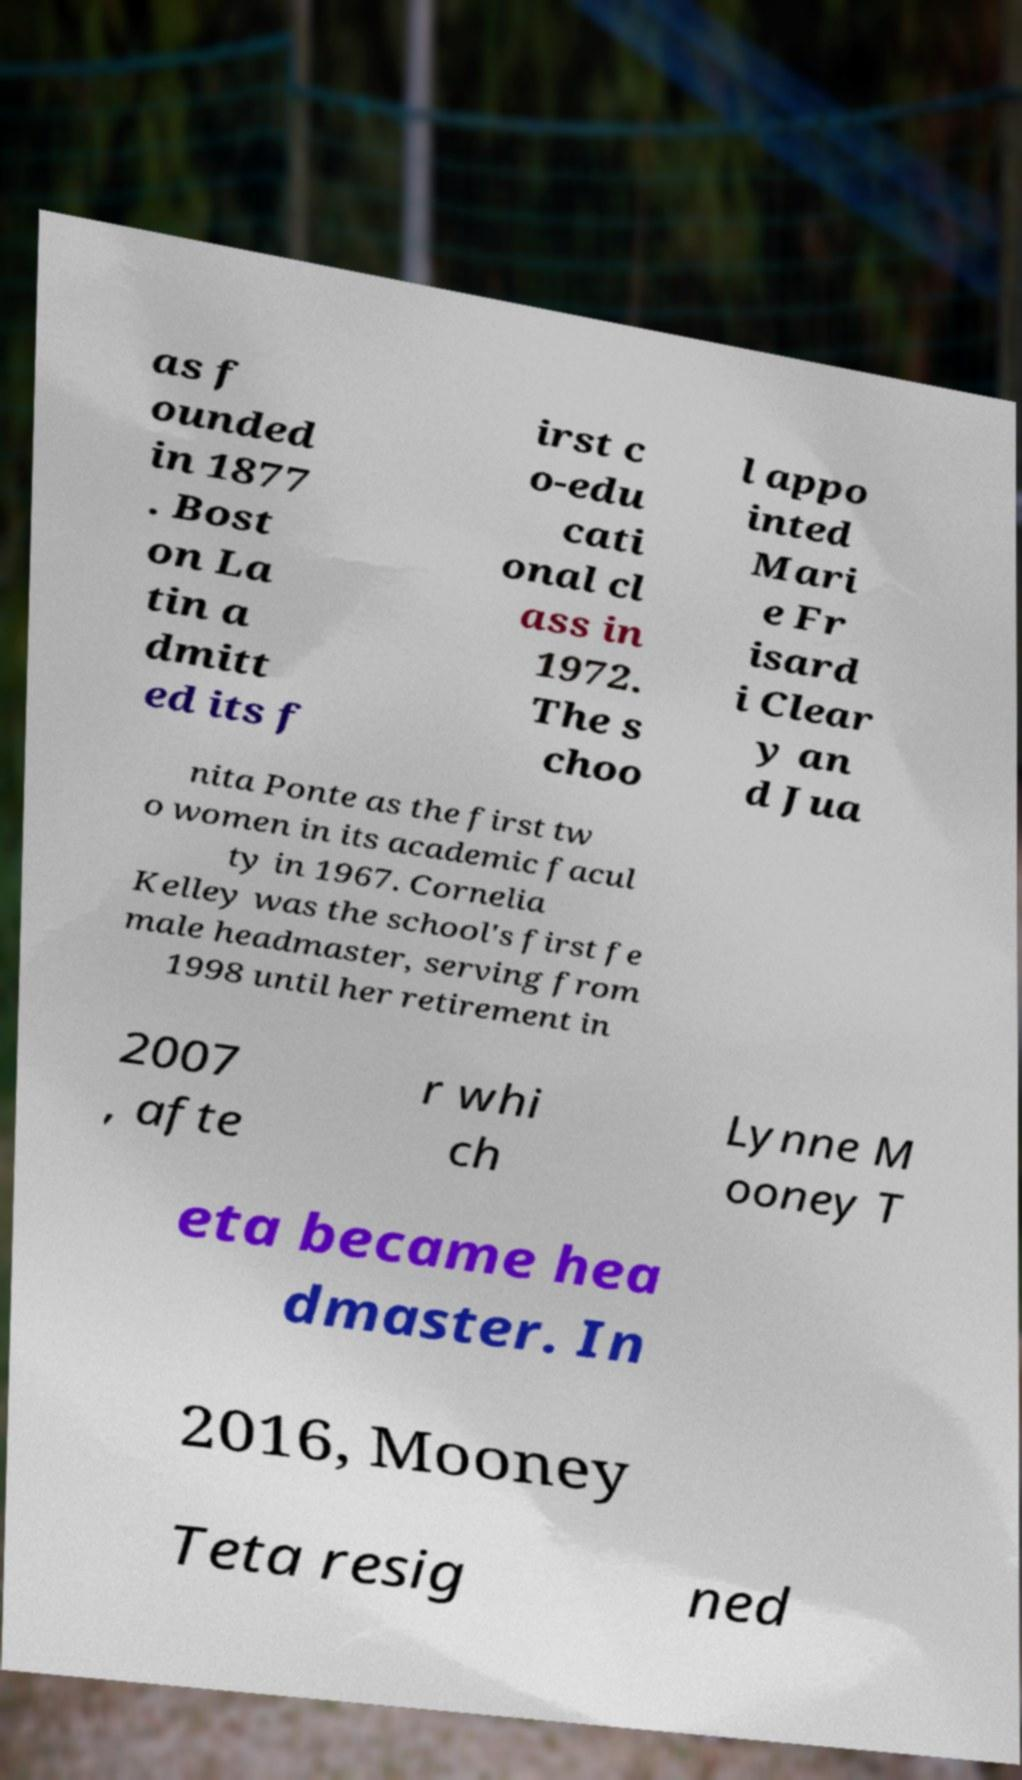For documentation purposes, I need the text within this image transcribed. Could you provide that? as f ounded in 1877 . Bost on La tin a dmitt ed its f irst c o-edu cati onal cl ass in 1972. The s choo l appo inted Mari e Fr isard i Clear y an d Jua nita Ponte as the first tw o women in its academic facul ty in 1967. Cornelia Kelley was the school's first fe male headmaster, serving from 1998 until her retirement in 2007 , afte r whi ch Lynne M ooney T eta became hea dmaster. In 2016, Mooney Teta resig ned 